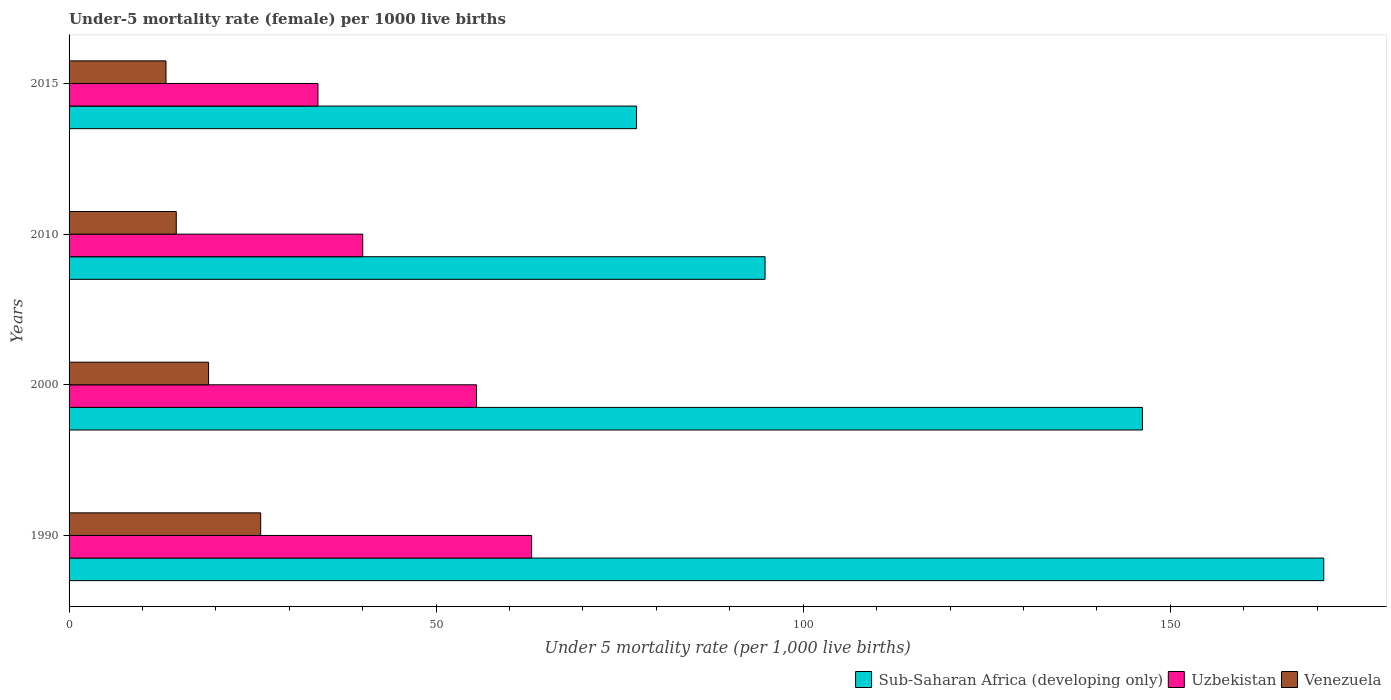How many different coloured bars are there?
Ensure brevity in your answer.  3. How many groups of bars are there?
Give a very brief answer. 4. Are the number of bars per tick equal to the number of legend labels?
Offer a very short reply. Yes. What is the label of the 2nd group of bars from the top?
Give a very brief answer. 2010. In how many cases, is the number of bars for a given year not equal to the number of legend labels?
Keep it short and to the point. 0. What is the under-five mortality rate in Venezuela in 1990?
Your response must be concise. 26.1. Across all years, what is the maximum under-five mortality rate in Sub-Saharan Africa (developing only)?
Ensure brevity in your answer.  170.9. In which year was the under-five mortality rate in Venezuela minimum?
Ensure brevity in your answer.  2015. What is the total under-five mortality rate in Uzbekistan in the graph?
Provide a succinct answer. 192.4. What is the difference between the under-five mortality rate in Sub-Saharan Africa (developing only) in 1990 and that in 2010?
Keep it short and to the point. 76.1. What is the difference between the under-five mortality rate in Sub-Saharan Africa (developing only) in 1990 and the under-five mortality rate in Venezuela in 2010?
Your answer should be very brief. 156.3. What is the average under-five mortality rate in Uzbekistan per year?
Offer a very short reply. 48.1. In the year 2000, what is the difference between the under-five mortality rate in Venezuela and under-five mortality rate in Sub-Saharan Africa (developing only)?
Provide a succinct answer. -127.2. What is the ratio of the under-five mortality rate in Venezuela in 1990 to that in 2015?
Offer a terse response. 1.98. Is the under-five mortality rate in Venezuela in 2000 less than that in 2015?
Your answer should be compact. No. What is the difference between the highest and the second highest under-five mortality rate in Sub-Saharan Africa (developing only)?
Your answer should be compact. 24.7. What is the difference between the highest and the lowest under-five mortality rate in Venezuela?
Provide a short and direct response. 12.9. In how many years, is the under-five mortality rate in Sub-Saharan Africa (developing only) greater than the average under-five mortality rate in Sub-Saharan Africa (developing only) taken over all years?
Give a very brief answer. 2. Is the sum of the under-five mortality rate in Uzbekistan in 1990 and 2010 greater than the maximum under-five mortality rate in Sub-Saharan Africa (developing only) across all years?
Offer a terse response. No. What does the 1st bar from the top in 2000 represents?
Give a very brief answer. Venezuela. What does the 3rd bar from the bottom in 2015 represents?
Your response must be concise. Venezuela. Is it the case that in every year, the sum of the under-five mortality rate in Venezuela and under-five mortality rate in Sub-Saharan Africa (developing only) is greater than the under-five mortality rate in Uzbekistan?
Keep it short and to the point. Yes. How many years are there in the graph?
Make the answer very short. 4. Does the graph contain any zero values?
Give a very brief answer. No. Does the graph contain grids?
Provide a short and direct response. No. Where does the legend appear in the graph?
Provide a succinct answer. Bottom right. How many legend labels are there?
Keep it short and to the point. 3. What is the title of the graph?
Provide a short and direct response. Under-5 mortality rate (female) per 1000 live births. What is the label or title of the X-axis?
Offer a very short reply. Under 5 mortality rate (per 1,0 live births). What is the label or title of the Y-axis?
Make the answer very short. Years. What is the Under 5 mortality rate (per 1,000 live births) in Sub-Saharan Africa (developing only) in 1990?
Offer a very short reply. 170.9. What is the Under 5 mortality rate (per 1,000 live births) of Venezuela in 1990?
Provide a succinct answer. 26.1. What is the Under 5 mortality rate (per 1,000 live births) in Sub-Saharan Africa (developing only) in 2000?
Ensure brevity in your answer.  146.2. What is the Under 5 mortality rate (per 1,000 live births) of Uzbekistan in 2000?
Your answer should be very brief. 55.5. What is the Under 5 mortality rate (per 1,000 live births) of Sub-Saharan Africa (developing only) in 2010?
Offer a terse response. 94.8. What is the Under 5 mortality rate (per 1,000 live births) of Uzbekistan in 2010?
Make the answer very short. 40. What is the Under 5 mortality rate (per 1,000 live births) in Venezuela in 2010?
Your answer should be compact. 14.6. What is the Under 5 mortality rate (per 1,000 live births) in Sub-Saharan Africa (developing only) in 2015?
Your answer should be very brief. 77.3. What is the Under 5 mortality rate (per 1,000 live births) in Uzbekistan in 2015?
Your response must be concise. 33.9. Across all years, what is the maximum Under 5 mortality rate (per 1,000 live births) of Sub-Saharan Africa (developing only)?
Provide a short and direct response. 170.9. Across all years, what is the maximum Under 5 mortality rate (per 1,000 live births) of Venezuela?
Make the answer very short. 26.1. Across all years, what is the minimum Under 5 mortality rate (per 1,000 live births) in Sub-Saharan Africa (developing only)?
Keep it short and to the point. 77.3. Across all years, what is the minimum Under 5 mortality rate (per 1,000 live births) of Uzbekistan?
Provide a succinct answer. 33.9. Across all years, what is the minimum Under 5 mortality rate (per 1,000 live births) of Venezuela?
Offer a terse response. 13.2. What is the total Under 5 mortality rate (per 1,000 live births) of Sub-Saharan Africa (developing only) in the graph?
Your answer should be compact. 489.2. What is the total Under 5 mortality rate (per 1,000 live births) of Uzbekistan in the graph?
Provide a succinct answer. 192.4. What is the total Under 5 mortality rate (per 1,000 live births) of Venezuela in the graph?
Offer a very short reply. 72.9. What is the difference between the Under 5 mortality rate (per 1,000 live births) of Sub-Saharan Africa (developing only) in 1990 and that in 2000?
Provide a succinct answer. 24.7. What is the difference between the Under 5 mortality rate (per 1,000 live births) in Uzbekistan in 1990 and that in 2000?
Provide a short and direct response. 7.5. What is the difference between the Under 5 mortality rate (per 1,000 live births) in Sub-Saharan Africa (developing only) in 1990 and that in 2010?
Provide a succinct answer. 76.1. What is the difference between the Under 5 mortality rate (per 1,000 live births) of Uzbekistan in 1990 and that in 2010?
Offer a very short reply. 23. What is the difference between the Under 5 mortality rate (per 1,000 live births) in Sub-Saharan Africa (developing only) in 1990 and that in 2015?
Your response must be concise. 93.6. What is the difference between the Under 5 mortality rate (per 1,000 live births) of Uzbekistan in 1990 and that in 2015?
Ensure brevity in your answer.  29.1. What is the difference between the Under 5 mortality rate (per 1,000 live births) of Venezuela in 1990 and that in 2015?
Offer a terse response. 12.9. What is the difference between the Under 5 mortality rate (per 1,000 live births) in Sub-Saharan Africa (developing only) in 2000 and that in 2010?
Keep it short and to the point. 51.4. What is the difference between the Under 5 mortality rate (per 1,000 live births) in Venezuela in 2000 and that in 2010?
Your response must be concise. 4.4. What is the difference between the Under 5 mortality rate (per 1,000 live births) of Sub-Saharan Africa (developing only) in 2000 and that in 2015?
Give a very brief answer. 68.9. What is the difference between the Under 5 mortality rate (per 1,000 live births) in Uzbekistan in 2000 and that in 2015?
Keep it short and to the point. 21.6. What is the difference between the Under 5 mortality rate (per 1,000 live births) of Sub-Saharan Africa (developing only) in 2010 and that in 2015?
Provide a succinct answer. 17.5. What is the difference between the Under 5 mortality rate (per 1,000 live births) in Venezuela in 2010 and that in 2015?
Your response must be concise. 1.4. What is the difference between the Under 5 mortality rate (per 1,000 live births) of Sub-Saharan Africa (developing only) in 1990 and the Under 5 mortality rate (per 1,000 live births) of Uzbekistan in 2000?
Keep it short and to the point. 115.4. What is the difference between the Under 5 mortality rate (per 1,000 live births) of Sub-Saharan Africa (developing only) in 1990 and the Under 5 mortality rate (per 1,000 live births) of Venezuela in 2000?
Your response must be concise. 151.9. What is the difference between the Under 5 mortality rate (per 1,000 live births) in Uzbekistan in 1990 and the Under 5 mortality rate (per 1,000 live births) in Venezuela in 2000?
Your answer should be very brief. 44. What is the difference between the Under 5 mortality rate (per 1,000 live births) of Sub-Saharan Africa (developing only) in 1990 and the Under 5 mortality rate (per 1,000 live births) of Uzbekistan in 2010?
Your answer should be very brief. 130.9. What is the difference between the Under 5 mortality rate (per 1,000 live births) in Sub-Saharan Africa (developing only) in 1990 and the Under 5 mortality rate (per 1,000 live births) in Venezuela in 2010?
Your answer should be compact. 156.3. What is the difference between the Under 5 mortality rate (per 1,000 live births) of Uzbekistan in 1990 and the Under 5 mortality rate (per 1,000 live births) of Venezuela in 2010?
Keep it short and to the point. 48.4. What is the difference between the Under 5 mortality rate (per 1,000 live births) in Sub-Saharan Africa (developing only) in 1990 and the Under 5 mortality rate (per 1,000 live births) in Uzbekistan in 2015?
Offer a very short reply. 137. What is the difference between the Under 5 mortality rate (per 1,000 live births) in Sub-Saharan Africa (developing only) in 1990 and the Under 5 mortality rate (per 1,000 live births) in Venezuela in 2015?
Your answer should be very brief. 157.7. What is the difference between the Under 5 mortality rate (per 1,000 live births) in Uzbekistan in 1990 and the Under 5 mortality rate (per 1,000 live births) in Venezuela in 2015?
Your response must be concise. 49.8. What is the difference between the Under 5 mortality rate (per 1,000 live births) of Sub-Saharan Africa (developing only) in 2000 and the Under 5 mortality rate (per 1,000 live births) of Uzbekistan in 2010?
Ensure brevity in your answer.  106.2. What is the difference between the Under 5 mortality rate (per 1,000 live births) in Sub-Saharan Africa (developing only) in 2000 and the Under 5 mortality rate (per 1,000 live births) in Venezuela in 2010?
Provide a succinct answer. 131.6. What is the difference between the Under 5 mortality rate (per 1,000 live births) in Uzbekistan in 2000 and the Under 5 mortality rate (per 1,000 live births) in Venezuela in 2010?
Your answer should be compact. 40.9. What is the difference between the Under 5 mortality rate (per 1,000 live births) of Sub-Saharan Africa (developing only) in 2000 and the Under 5 mortality rate (per 1,000 live births) of Uzbekistan in 2015?
Your answer should be compact. 112.3. What is the difference between the Under 5 mortality rate (per 1,000 live births) of Sub-Saharan Africa (developing only) in 2000 and the Under 5 mortality rate (per 1,000 live births) of Venezuela in 2015?
Your answer should be very brief. 133. What is the difference between the Under 5 mortality rate (per 1,000 live births) in Uzbekistan in 2000 and the Under 5 mortality rate (per 1,000 live births) in Venezuela in 2015?
Provide a succinct answer. 42.3. What is the difference between the Under 5 mortality rate (per 1,000 live births) in Sub-Saharan Africa (developing only) in 2010 and the Under 5 mortality rate (per 1,000 live births) in Uzbekistan in 2015?
Ensure brevity in your answer.  60.9. What is the difference between the Under 5 mortality rate (per 1,000 live births) in Sub-Saharan Africa (developing only) in 2010 and the Under 5 mortality rate (per 1,000 live births) in Venezuela in 2015?
Provide a succinct answer. 81.6. What is the difference between the Under 5 mortality rate (per 1,000 live births) of Uzbekistan in 2010 and the Under 5 mortality rate (per 1,000 live births) of Venezuela in 2015?
Keep it short and to the point. 26.8. What is the average Under 5 mortality rate (per 1,000 live births) in Sub-Saharan Africa (developing only) per year?
Offer a very short reply. 122.3. What is the average Under 5 mortality rate (per 1,000 live births) of Uzbekistan per year?
Your answer should be very brief. 48.1. What is the average Under 5 mortality rate (per 1,000 live births) of Venezuela per year?
Your response must be concise. 18.23. In the year 1990, what is the difference between the Under 5 mortality rate (per 1,000 live births) of Sub-Saharan Africa (developing only) and Under 5 mortality rate (per 1,000 live births) of Uzbekistan?
Ensure brevity in your answer.  107.9. In the year 1990, what is the difference between the Under 5 mortality rate (per 1,000 live births) of Sub-Saharan Africa (developing only) and Under 5 mortality rate (per 1,000 live births) of Venezuela?
Keep it short and to the point. 144.8. In the year 1990, what is the difference between the Under 5 mortality rate (per 1,000 live births) in Uzbekistan and Under 5 mortality rate (per 1,000 live births) in Venezuela?
Ensure brevity in your answer.  36.9. In the year 2000, what is the difference between the Under 5 mortality rate (per 1,000 live births) in Sub-Saharan Africa (developing only) and Under 5 mortality rate (per 1,000 live births) in Uzbekistan?
Offer a terse response. 90.7. In the year 2000, what is the difference between the Under 5 mortality rate (per 1,000 live births) of Sub-Saharan Africa (developing only) and Under 5 mortality rate (per 1,000 live births) of Venezuela?
Provide a short and direct response. 127.2. In the year 2000, what is the difference between the Under 5 mortality rate (per 1,000 live births) of Uzbekistan and Under 5 mortality rate (per 1,000 live births) of Venezuela?
Your answer should be very brief. 36.5. In the year 2010, what is the difference between the Under 5 mortality rate (per 1,000 live births) in Sub-Saharan Africa (developing only) and Under 5 mortality rate (per 1,000 live births) in Uzbekistan?
Offer a very short reply. 54.8. In the year 2010, what is the difference between the Under 5 mortality rate (per 1,000 live births) of Sub-Saharan Africa (developing only) and Under 5 mortality rate (per 1,000 live births) of Venezuela?
Your answer should be compact. 80.2. In the year 2010, what is the difference between the Under 5 mortality rate (per 1,000 live births) of Uzbekistan and Under 5 mortality rate (per 1,000 live births) of Venezuela?
Provide a succinct answer. 25.4. In the year 2015, what is the difference between the Under 5 mortality rate (per 1,000 live births) in Sub-Saharan Africa (developing only) and Under 5 mortality rate (per 1,000 live births) in Uzbekistan?
Make the answer very short. 43.4. In the year 2015, what is the difference between the Under 5 mortality rate (per 1,000 live births) in Sub-Saharan Africa (developing only) and Under 5 mortality rate (per 1,000 live births) in Venezuela?
Your response must be concise. 64.1. In the year 2015, what is the difference between the Under 5 mortality rate (per 1,000 live births) in Uzbekistan and Under 5 mortality rate (per 1,000 live births) in Venezuela?
Provide a succinct answer. 20.7. What is the ratio of the Under 5 mortality rate (per 1,000 live births) of Sub-Saharan Africa (developing only) in 1990 to that in 2000?
Your answer should be very brief. 1.17. What is the ratio of the Under 5 mortality rate (per 1,000 live births) of Uzbekistan in 1990 to that in 2000?
Your response must be concise. 1.14. What is the ratio of the Under 5 mortality rate (per 1,000 live births) of Venezuela in 1990 to that in 2000?
Ensure brevity in your answer.  1.37. What is the ratio of the Under 5 mortality rate (per 1,000 live births) in Sub-Saharan Africa (developing only) in 1990 to that in 2010?
Your response must be concise. 1.8. What is the ratio of the Under 5 mortality rate (per 1,000 live births) in Uzbekistan in 1990 to that in 2010?
Your answer should be very brief. 1.57. What is the ratio of the Under 5 mortality rate (per 1,000 live births) in Venezuela in 1990 to that in 2010?
Keep it short and to the point. 1.79. What is the ratio of the Under 5 mortality rate (per 1,000 live births) in Sub-Saharan Africa (developing only) in 1990 to that in 2015?
Keep it short and to the point. 2.21. What is the ratio of the Under 5 mortality rate (per 1,000 live births) of Uzbekistan in 1990 to that in 2015?
Provide a succinct answer. 1.86. What is the ratio of the Under 5 mortality rate (per 1,000 live births) of Venezuela in 1990 to that in 2015?
Ensure brevity in your answer.  1.98. What is the ratio of the Under 5 mortality rate (per 1,000 live births) of Sub-Saharan Africa (developing only) in 2000 to that in 2010?
Provide a short and direct response. 1.54. What is the ratio of the Under 5 mortality rate (per 1,000 live births) in Uzbekistan in 2000 to that in 2010?
Give a very brief answer. 1.39. What is the ratio of the Under 5 mortality rate (per 1,000 live births) in Venezuela in 2000 to that in 2010?
Offer a terse response. 1.3. What is the ratio of the Under 5 mortality rate (per 1,000 live births) of Sub-Saharan Africa (developing only) in 2000 to that in 2015?
Your response must be concise. 1.89. What is the ratio of the Under 5 mortality rate (per 1,000 live births) in Uzbekistan in 2000 to that in 2015?
Provide a short and direct response. 1.64. What is the ratio of the Under 5 mortality rate (per 1,000 live births) of Venezuela in 2000 to that in 2015?
Provide a short and direct response. 1.44. What is the ratio of the Under 5 mortality rate (per 1,000 live births) in Sub-Saharan Africa (developing only) in 2010 to that in 2015?
Offer a very short reply. 1.23. What is the ratio of the Under 5 mortality rate (per 1,000 live births) of Uzbekistan in 2010 to that in 2015?
Your answer should be compact. 1.18. What is the ratio of the Under 5 mortality rate (per 1,000 live births) of Venezuela in 2010 to that in 2015?
Offer a terse response. 1.11. What is the difference between the highest and the second highest Under 5 mortality rate (per 1,000 live births) of Sub-Saharan Africa (developing only)?
Give a very brief answer. 24.7. What is the difference between the highest and the second highest Under 5 mortality rate (per 1,000 live births) of Uzbekistan?
Offer a very short reply. 7.5. What is the difference between the highest and the second highest Under 5 mortality rate (per 1,000 live births) in Venezuela?
Ensure brevity in your answer.  7.1. What is the difference between the highest and the lowest Under 5 mortality rate (per 1,000 live births) of Sub-Saharan Africa (developing only)?
Your answer should be very brief. 93.6. What is the difference between the highest and the lowest Under 5 mortality rate (per 1,000 live births) in Uzbekistan?
Keep it short and to the point. 29.1. What is the difference between the highest and the lowest Under 5 mortality rate (per 1,000 live births) in Venezuela?
Offer a very short reply. 12.9. 